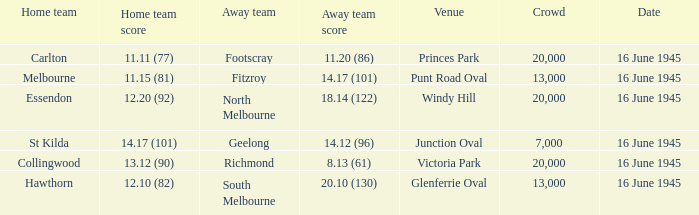What was the Home team score for the team that played South Melbourne? 12.10 (82). 